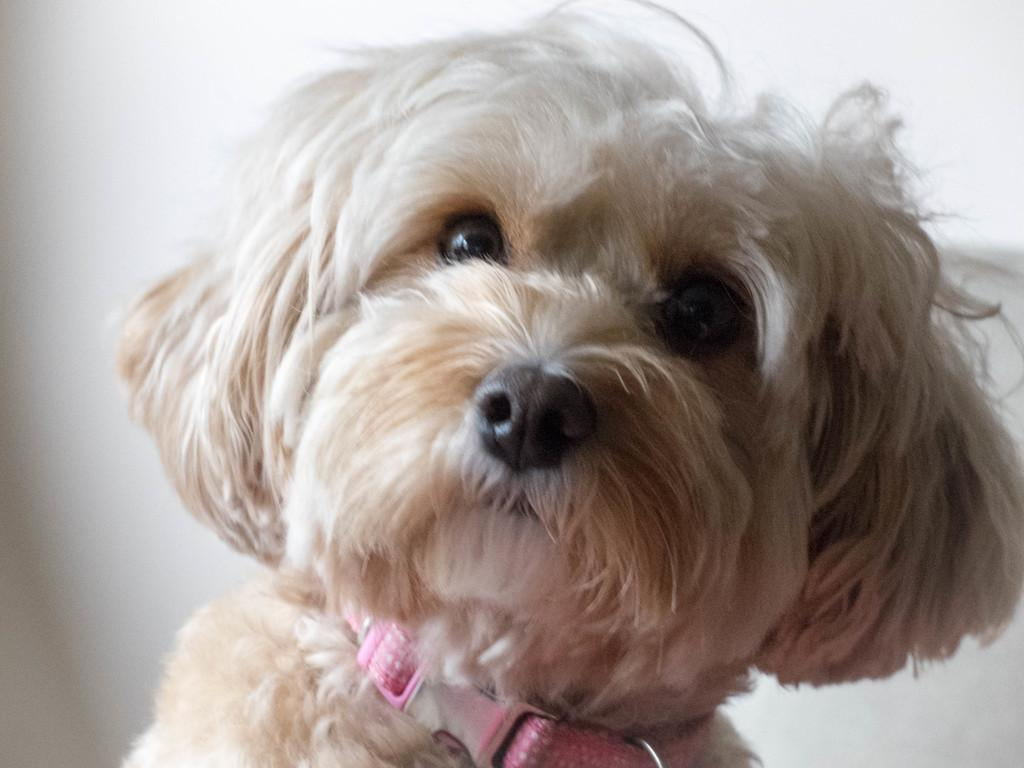What type of animal is present in the image? There is a dog in the image. Can you describe the color of the dog? The dog is in cream color. What other object can be seen in the image? There is a wall in the image. What is the color of the wall? The wall is also in cream color. How does the dog contribute to pollution in the image? The image does not show any evidence of pollution, and the dog's presence does not contribute to pollution in the image. 